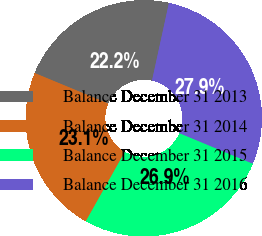Convert chart to OTSL. <chart><loc_0><loc_0><loc_500><loc_500><pie_chart><fcel>Balance December 31 2013<fcel>Balance December 31 2014<fcel>Balance December 31 2015<fcel>Balance December 31 2016<nl><fcel>22.16%<fcel>23.1%<fcel>26.88%<fcel>27.85%<nl></chart> 